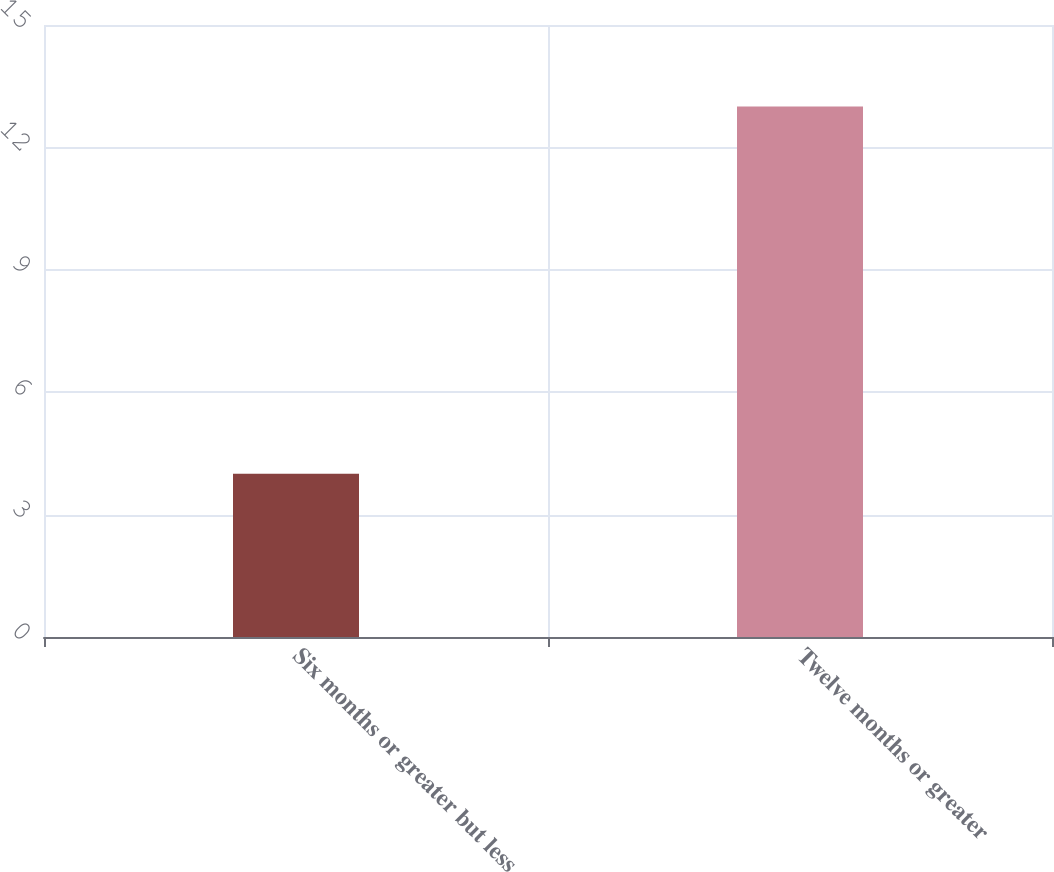Convert chart to OTSL. <chart><loc_0><loc_0><loc_500><loc_500><bar_chart><fcel>Six months or greater but less<fcel>Twelve months or greater<nl><fcel>4<fcel>13<nl></chart> 